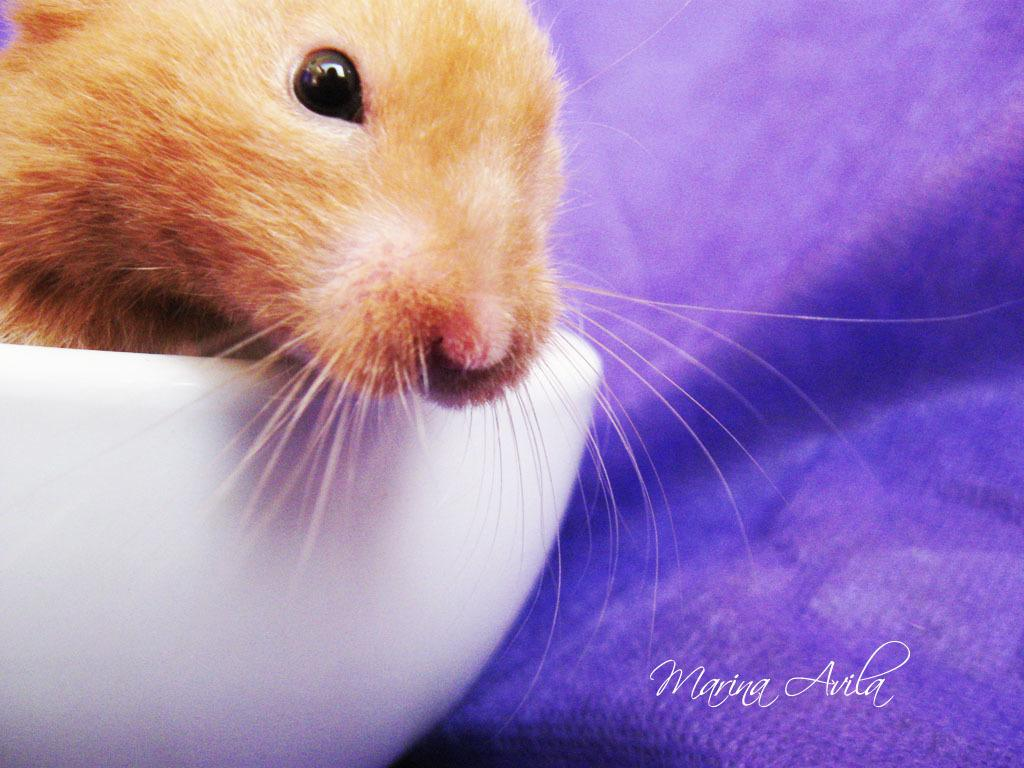What is in the bowl that is visible in the image? There is an animal in a bowl in the image. What color is the object on the right side of the image? The object on the right side of the image is purple. What ideas do the men in the image have about the bell? There are no men or bells present in the image, so it is not possible to answer that question. 